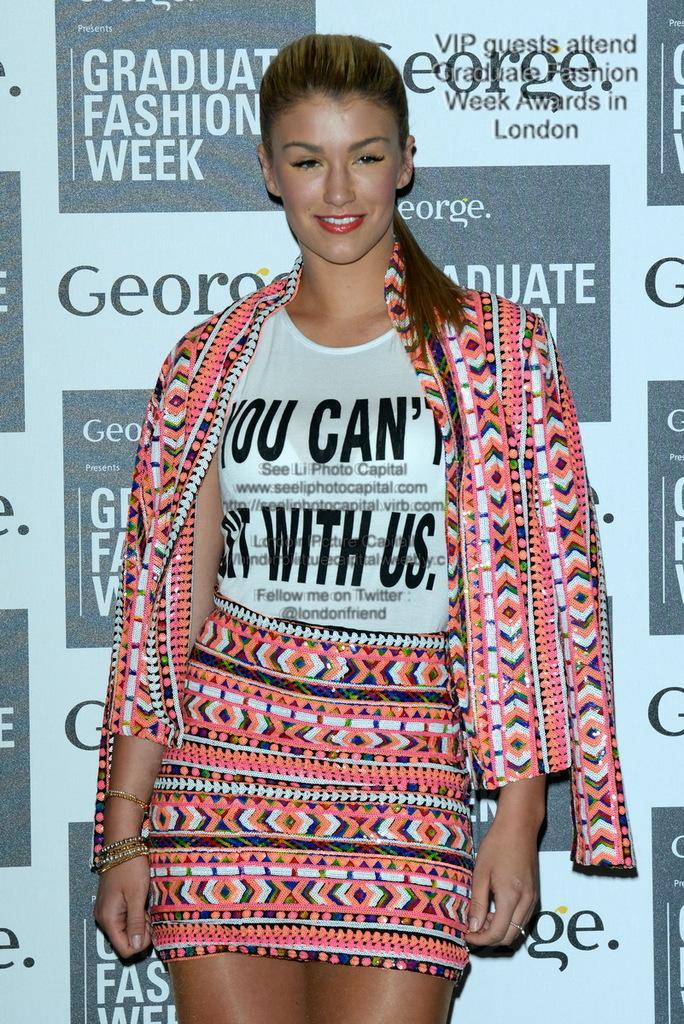Could you give a brief overview of what you see in this image? Here there is a woman standing. In the background there is a hoarding. 